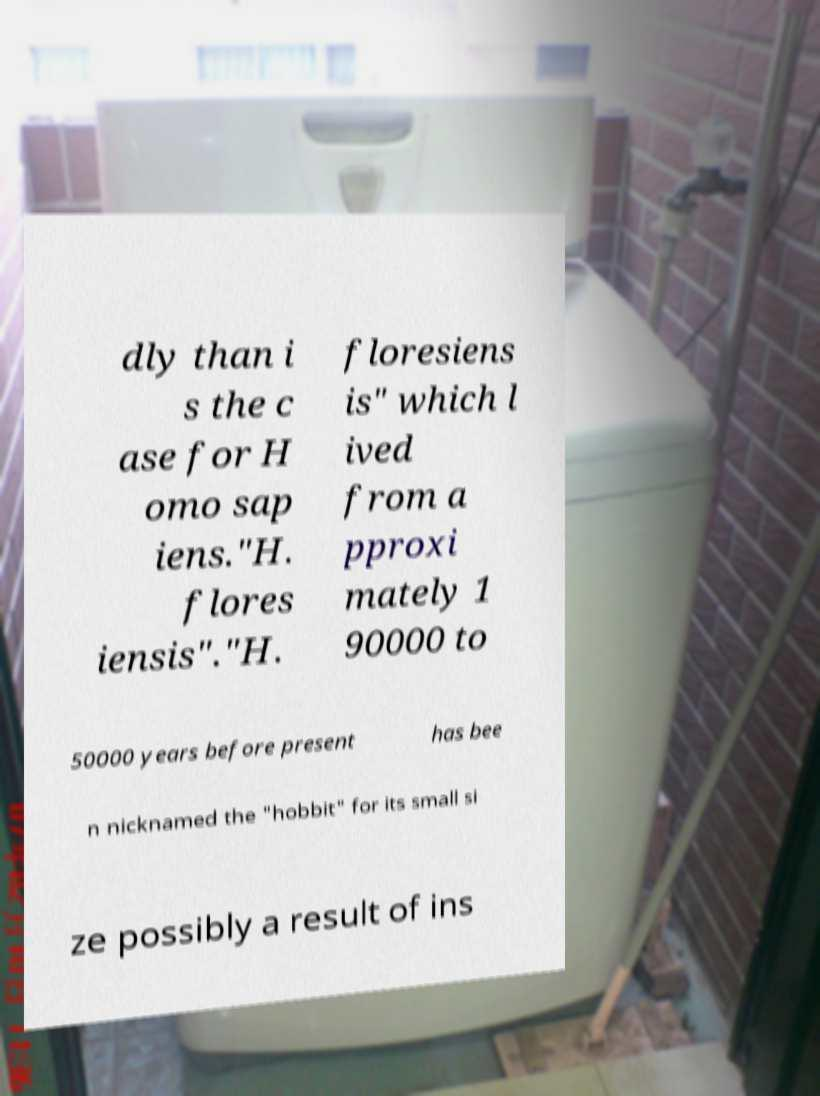Can you read and provide the text displayed in the image?This photo seems to have some interesting text. Can you extract and type it out for me? dly than i s the c ase for H omo sap iens."H. flores iensis"."H. floresiens is" which l ived from a pproxi mately 1 90000 to 50000 years before present has bee n nicknamed the "hobbit" for its small si ze possibly a result of ins 